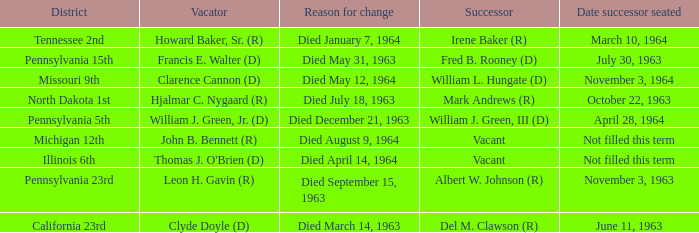What is every district for reason for change is died August 9, 1964? Michigan 12th. 